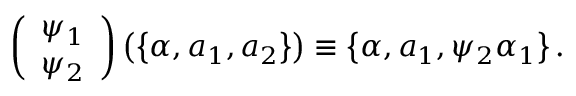Convert formula to latex. <formula><loc_0><loc_0><loc_500><loc_500>\left ( \begin{array} { c } { { \psi _ { 1 } } } \\ { { \psi _ { 2 } } } \end{array} \right ) \left ( \left \{ \alpha , a _ { 1 } , a _ { 2 } \right \} \right ) \equiv \left \{ \alpha , a _ { 1 } , \psi _ { 2 } \alpha _ { 1 } \right \} .</formula> 